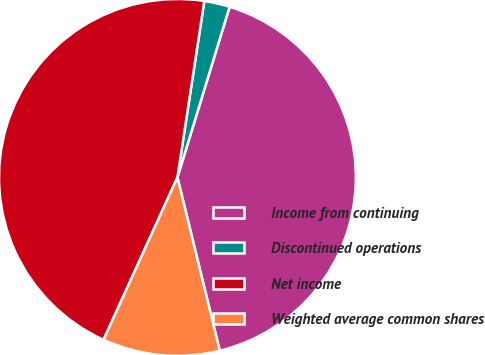Convert chart. <chart><loc_0><loc_0><loc_500><loc_500><pie_chart><fcel>Income from continuing<fcel>Discontinued operations<fcel>Net income<fcel>Weighted average common shares<nl><fcel>41.46%<fcel>2.32%<fcel>45.61%<fcel>10.61%<nl></chart> 